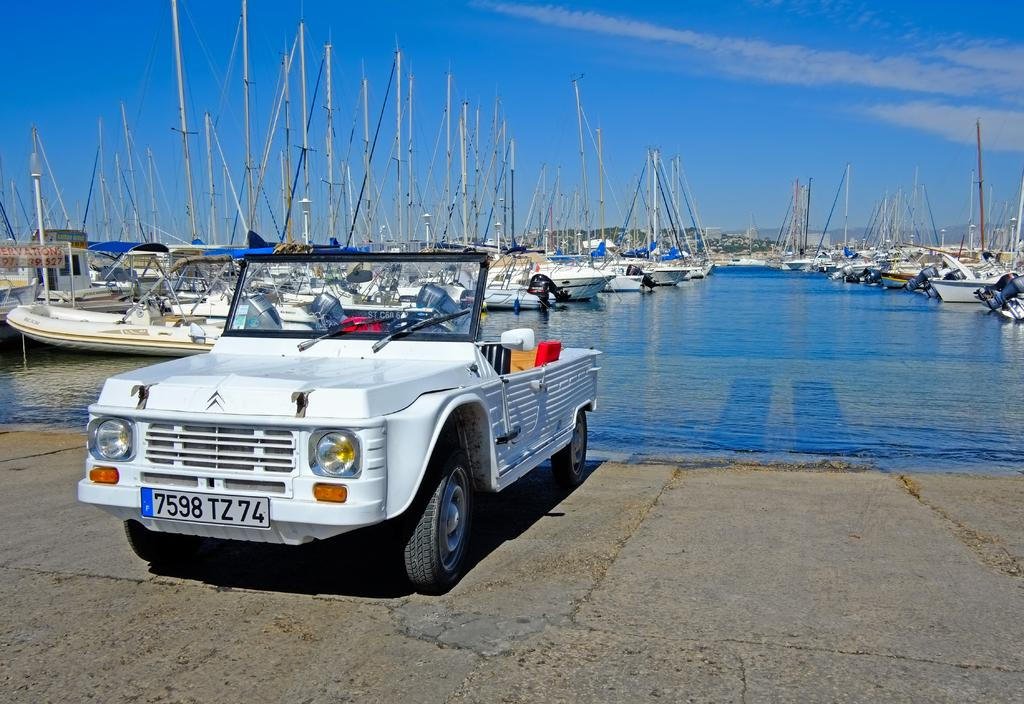What is happening in the image? There are boats on water in the image. What else can be seen in the image besides the boats? There is a white vehicle in the image. What is visible in the background of the image? The sky is visible in the background of the image. Can you see a thumbprint on the white vehicle in the image? There is no thumbprint visible on the white vehicle in the image. Is there a giraffe in the image? No, there is no giraffe present in the image. 